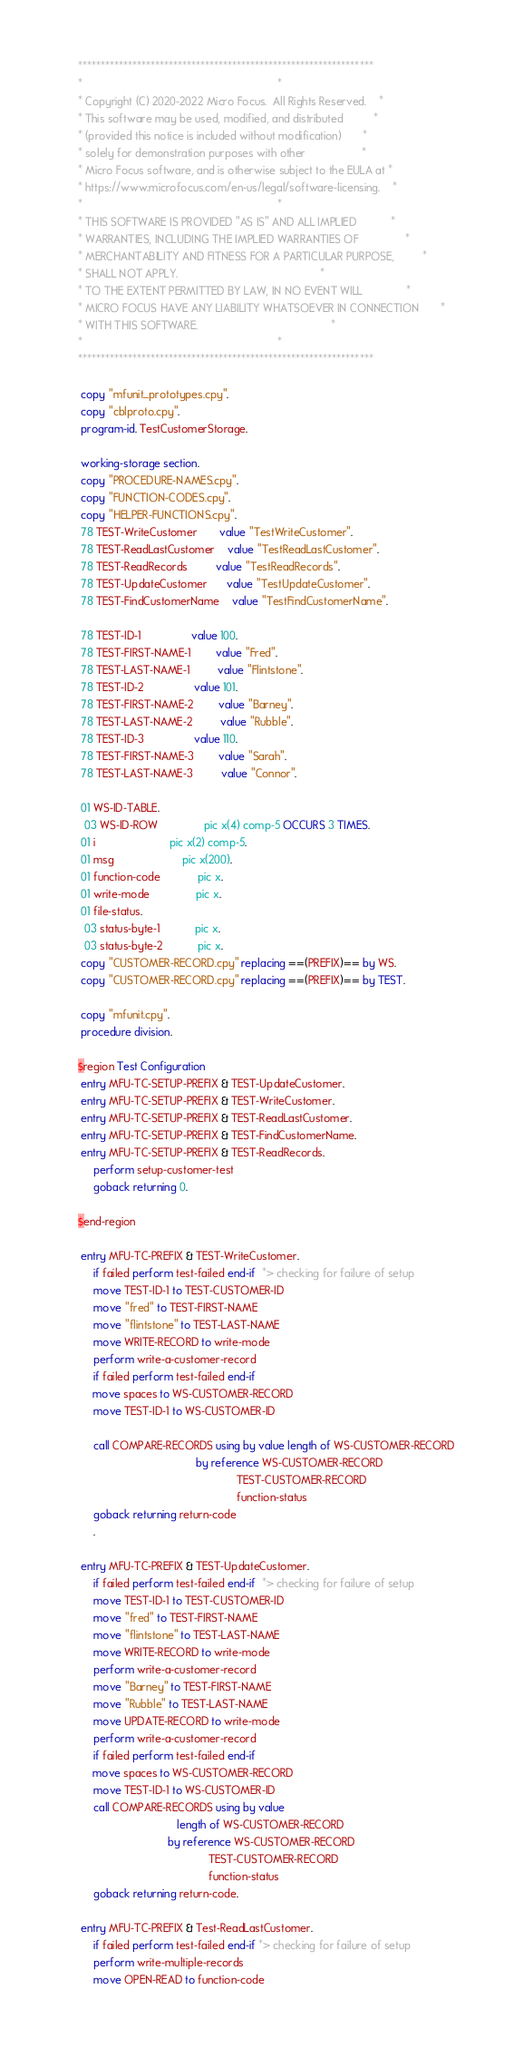<code> <loc_0><loc_0><loc_500><loc_500><_COBOL_>      *****************************************************************
      *                                                               *
      * Copyright (C) 2020-2022 Micro Focus.  All Rights Reserved.    *
      * This software may be used, modified, and distributed          *
      * (provided this notice is included without modification)       *
      * solely for demonstration purposes with other                  *
      * Micro Focus software, and is otherwise subject to the EULA at *
      * https://www.microfocus.com/en-us/legal/software-licensing.    *
      *                                                               *
      * THIS SOFTWARE IS PROVIDED "AS IS" AND ALL IMPLIED           *
      * WARRANTIES, INCLUDING THE IMPLIED WARRANTIES OF               *
      * MERCHANTABILITY AND FITNESS FOR A PARTICULAR PURPOSE,         *
      * SHALL NOT APPLY.                                              *
      * TO THE EXTENT PERMITTED BY LAW, IN NO EVENT WILL              *
      * MICRO FOCUS HAVE ANY LIABILITY WHATSOEVER IN CONNECTION       *
      * WITH THIS SOFTWARE.                                           *
      *                                                               *
      *****************************************************************
      
       copy "mfunit_prototypes.cpy".
       copy "cblproto.cpy". 
       program-id. TestCustomerStorage.

       working-storage section.
       copy "PROCEDURE-NAMES.cpy".
       copy "FUNCTION-CODES.cpy".
       copy "HELPER-FUNCTIONS.cpy". 
       78 TEST-WriteCustomer       value "TestWriteCustomer".
       78 TEST-ReadLastCustomer    value "TestReadLastCustomer". 
       78 TEST-ReadRecords         value "TestReadRecords". 
       78 TEST-UpdateCustomer      value "TestUpdateCustomer". 
       78 TEST-FindCustomerName    value "TestFindCustomerName".
       
       78 TEST-ID-1                value 100. 
       78 TEST-FIRST-NAME-1        value "Fred".
       78 TEST-LAST-NAME-1         value "Flintstone".
       78 TEST-ID-2                value 101. 
       78 TEST-FIRST-NAME-2        value "Barney". 
       78 TEST-LAST-NAME-2         value "Rubble".
       78 TEST-ID-3                value 110. 
       78 TEST-FIRST-NAME-3        value "Sarah". 
       78 TEST-LAST-NAME-3         value "Connor".
       
       01 WS-ID-TABLE.
        03 WS-ID-ROW               pic x(4) comp-5 OCCURS 3 TIMES. 
       01 i                        pic x(2) comp-5.
       01 msg                      pic x(200). 
       01 function-code            pic x. 
       01 write-mode               pic x. 
       01 file-status.
        03 status-byte-1           pic x.
        03 status-byte-2           pic x.
       copy "CUSTOMER-RECORD.cpy" replacing ==(PREFIX)== by WS.
       copy "CUSTOMER-RECORD.cpy" replacing ==(PREFIX)== by TEST. 
       
       copy "mfunit.cpy".
       procedure division.

      $region Test Configuration
       entry MFU-TC-SETUP-PREFIX & TEST-UpdateCustomer.
       entry MFU-TC-SETUP-PREFIX & TEST-WriteCustomer.
       entry MFU-TC-SETUP-PREFIX & TEST-ReadLastCustomer. 
       entry MFU-TC-SETUP-PREFIX & TEST-FindCustomerName. 
       entry MFU-TC-SETUP-PREFIX & TEST-ReadRecords.     
           perform setup-customer-test
           goback returning 0.
  
      $end-region

       entry MFU-TC-PREFIX & TEST-WriteCustomer.
           if failed perform test-failed end-if  *> checking for failure of setup
           move TEST-ID-1 to TEST-CUSTOMER-ID
           move "fred" to TEST-FIRST-NAME
           move "flintstone" to TEST-LAST-NAME
           move WRITE-RECORD to write-mode
           perform write-a-customer-record
           if failed perform test-failed end-if 
           move spaces to WS-CUSTOMER-RECORD
           move TEST-ID-1 to WS-CUSTOMER-ID
                               
           call COMPARE-RECORDS using by value length of WS-CUSTOMER-RECORD
                                            by reference WS-CUSTOMER-RECORD
                                                         TEST-CUSTOMER-RECORD  
                                                         function-status
           goback returning return-code
           .
           
       entry MFU-TC-PREFIX & TEST-UpdateCustomer.
           if failed perform test-failed end-if  *> checking for failure of setup
           move TEST-ID-1 to TEST-CUSTOMER-ID
           move "fred" to TEST-FIRST-NAME
           move "flintstone" to TEST-LAST-NAME
           move WRITE-RECORD to write-mode
           perform write-a-customer-record
           move "Barney" to TEST-FIRST-NAME
           move "Rubble" to TEST-LAST-NAME
           move UPDATE-RECORD to write-mode
           perform write-a-customer-record 
           if failed perform test-failed end-if
           move spaces to WS-CUSTOMER-RECORD
           move TEST-ID-1 to WS-CUSTOMER-ID
           call COMPARE-RECORDS using by value 
                                      length of WS-CUSTOMER-RECORD
                                   by reference WS-CUSTOMER-RECORD
                                                TEST-CUSTOMER-RECORD  
                                                function-status
           goback returning return-code. 
           
       entry MFU-TC-PREFIX & Test-ReadLastCustomer.
           if failed perform test-failed end-if *> checking for failure of setup
           perform write-multiple-records
           move OPEN-READ to function-code </code> 